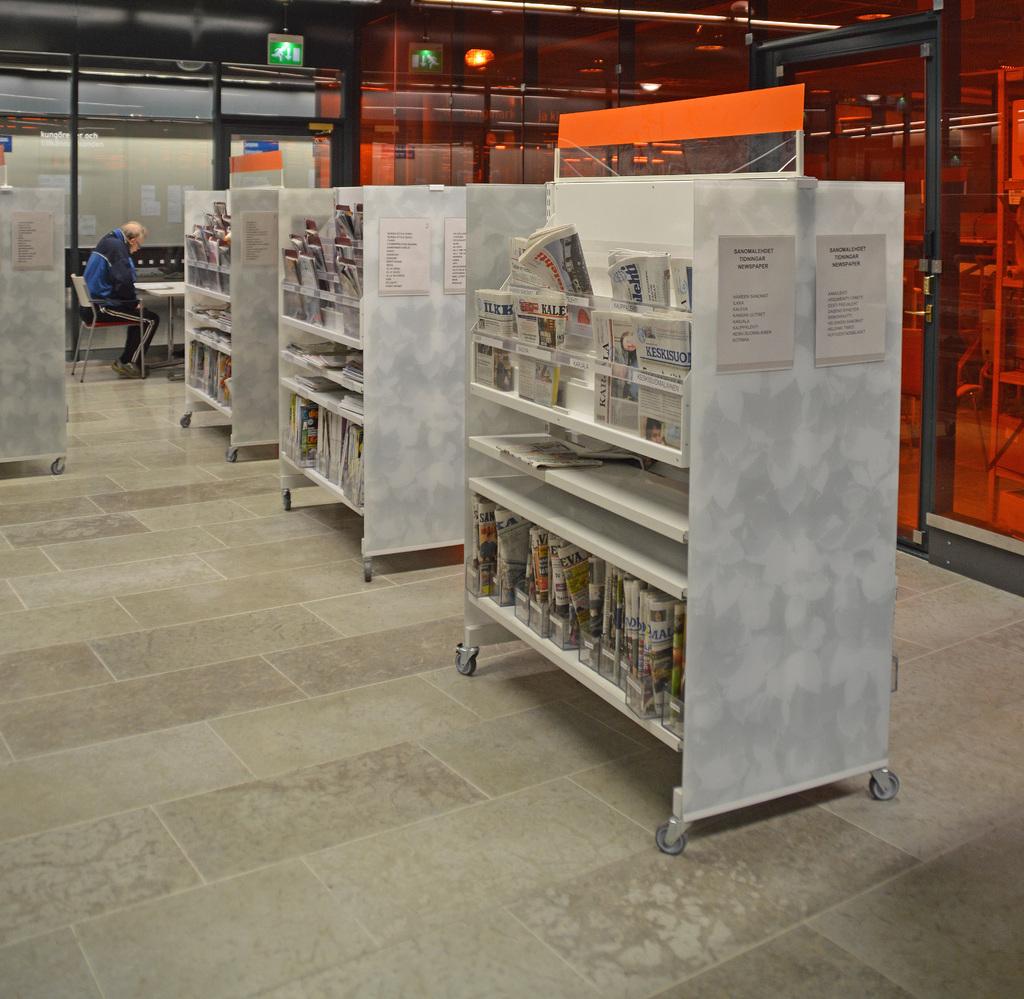Name one of the papers in the rack?
Your answer should be compact. Kale. 